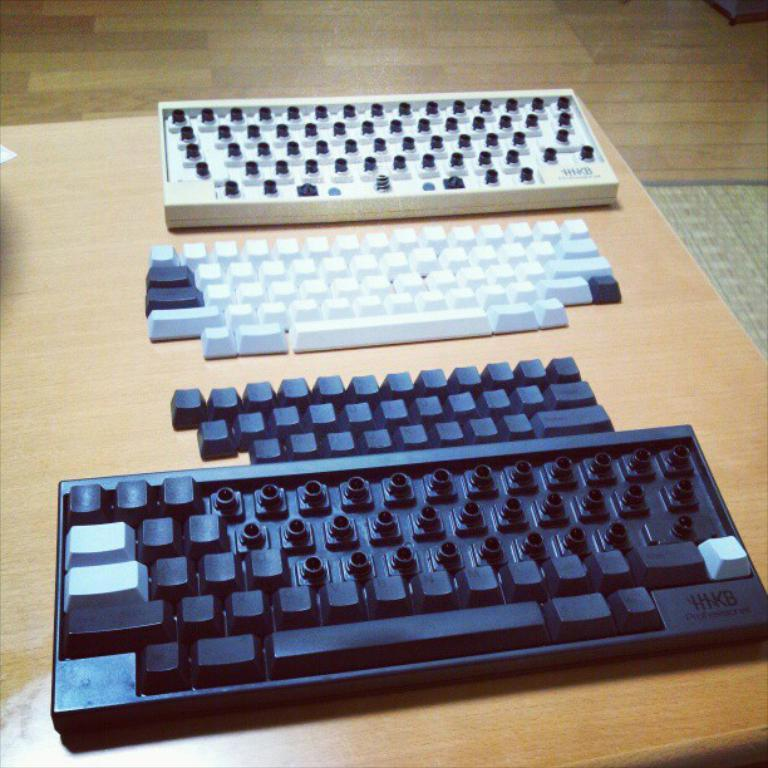Provide a one-sentence caption for the provided image. two HIKB keyboards taken apart on a table. 